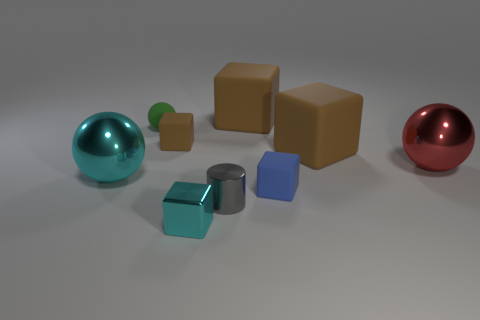What can you infer about the lighting in this scene based on the objects' appearances? The scene is well-lit with a diffuse light source, as evidenced by the soft shadows under each object and the lack of harsh, contrasting highlights. The lighting casts gentle reflections, particularly on the metallic and shiny surfaces, suggesting an ambient or overhead light that provides an even illumination across the entire setup. 